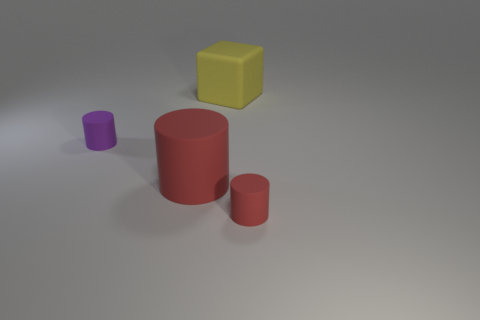Subtract all tiny purple matte cylinders. How many cylinders are left? 2 Subtract all cubes. How many objects are left? 3 Add 2 large gray rubber objects. How many objects exist? 6 Subtract 1 cubes. How many cubes are left? 0 Subtract all red cylinders. How many cylinders are left? 1 Add 4 yellow rubber blocks. How many yellow rubber blocks are left? 5 Add 3 big rubber cubes. How many big rubber cubes exist? 4 Subtract 0 purple blocks. How many objects are left? 4 Subtract all brown cubes. Subtract all green balls. How many cubes are left? 1 Subtract all green blocks. How many purple cylinders are left? 1 